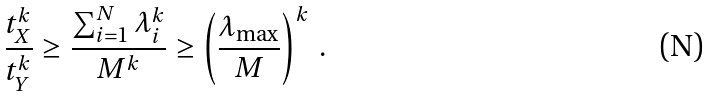<formula> <loc_0><loc_0><loc_500><loc_500>\frac { t _ { X } ^ { k } } { t _ { Y } ^ { k } } \geq \frac { \sum _ { i = 1 } ^ { N } \lambda _ { i } ^ { k } } { M ^ { k } } \geq \left ( \frac { \lambda _ { \max } } { M } \right ) ^ { k } \, .</formula> 